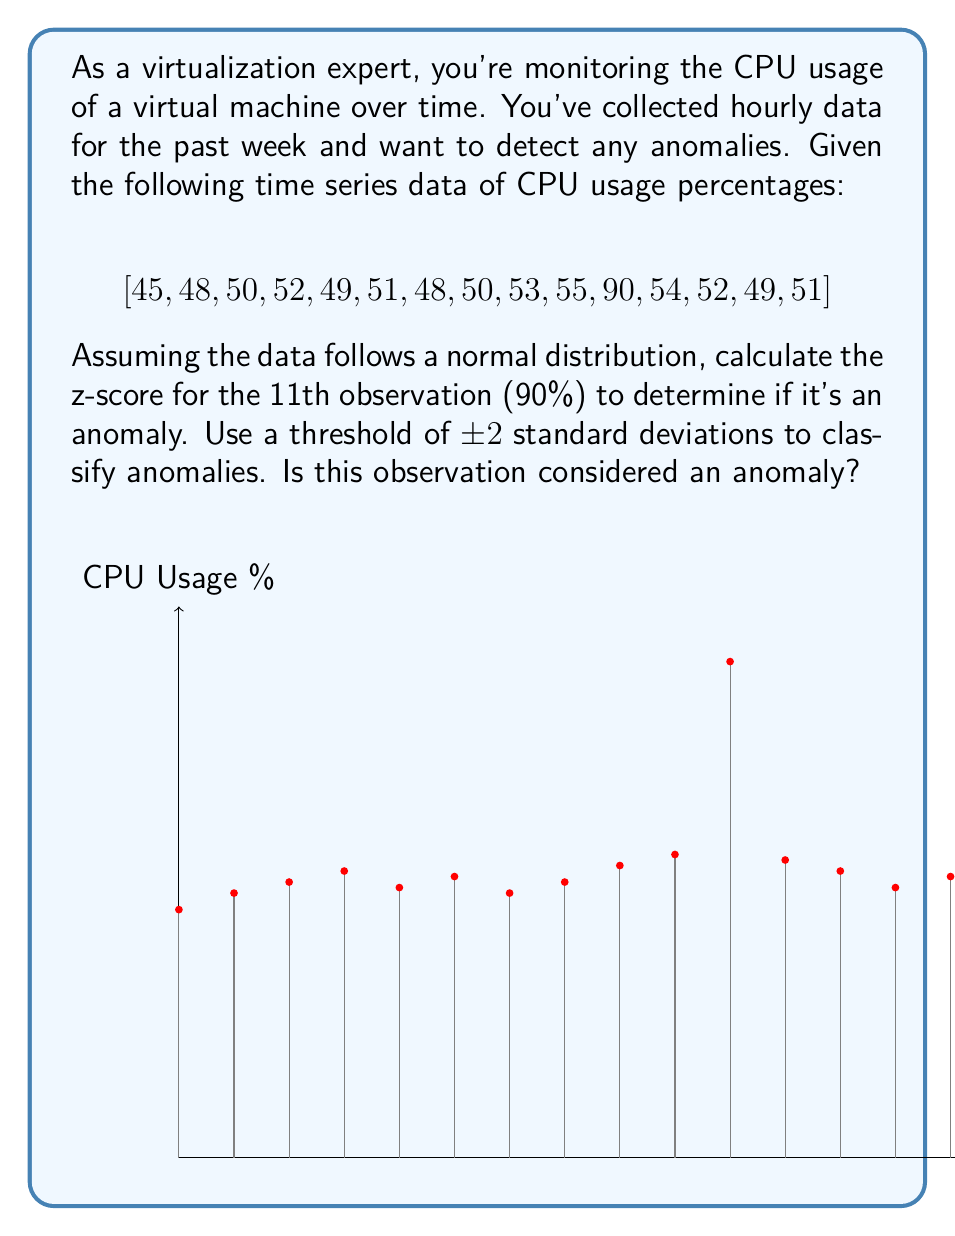Give your solution to this math problem. To determine if the 11th observation is an anomaly, we need to calculate its z-score and compare it to our threshold. Let's follow these steps:

1. Calculate the mean (μ) of the data:
   $$\mu = \frac{\sum_{i=1}^{n} x_i}{n} = \frac{797}{15} \approx 53.13$$

2. Calculate the standard deviation (σ) of the data:
   $$\sigma = \sqrt{\frac{\sum_{i=1}^{n} (x_i - \mu)^2}{n-1}}$$
   $$\sigma = \sqrt{\frac{1894.93}{14}} \approx 11.64$$

3. Calculate the z-score for the 11th observation (x = 90):
   $$z = \frac{x - \mu}{\sigma} = \frac{90 - 53.13}{11.64} \approx 3.17$$

4. Compare the z-score to our threshold:
   The absolute value of the z-score (3.17) is greater than our threshold of 2 standard deviations.

Therefore, the 11th observation (90% CPU usage) is considered an anomaly in this time series data.
Answer: Yes, z-score ≈ 3.17 > 2, anomaly detected. 